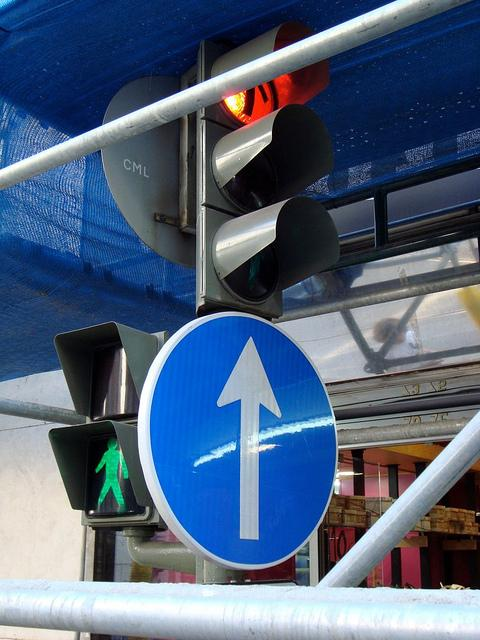What does the blue sign with a white arrow mean? up 